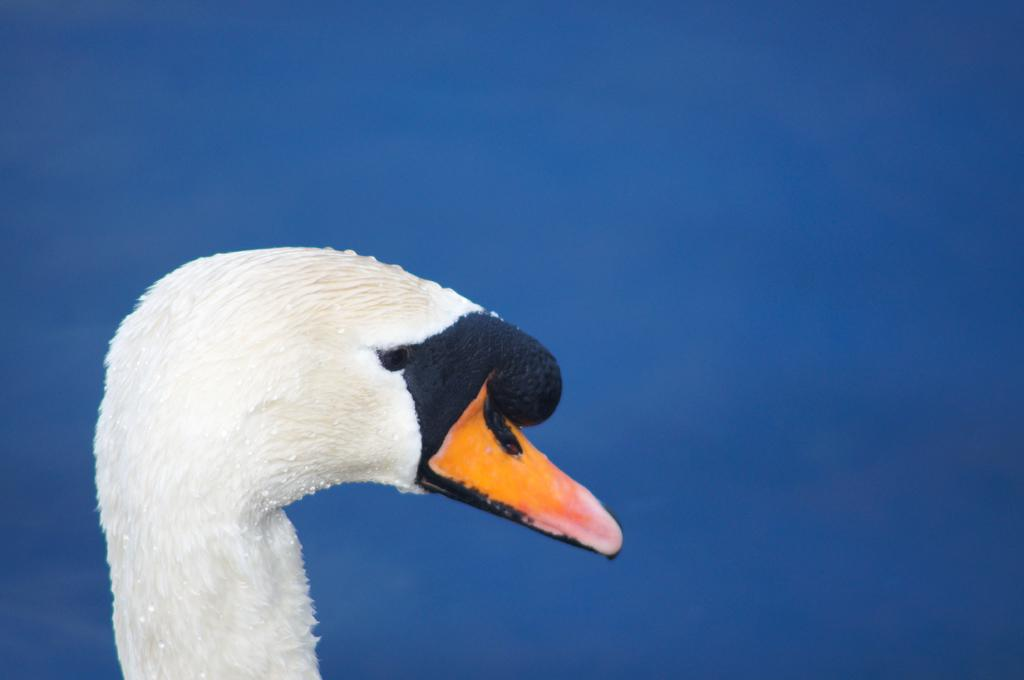What type of animal is partially visible in the image? There is a part of a duck in the image. What color is the duck's body? The duck has a white body. What color is the duck's face? The duck has a black face. What color is the duck's beak? The duck has a yellow beak. What color is the background of the image? The background of the image is blue. What type of sack can be seen in the image? There is no sack present in the image. What type of bucket can be seen in the image? There is no bucket present in the image. 